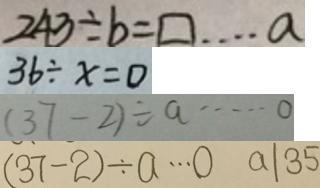<formula> <loc_0><loc_0><loc_500><loc_500>2 4 3 \div b = \square \cdots a 
 3 6 \div x = 0 
 ( 3 7 - 2 ) \div a \cdots 0 
 ( 3 7 - 2 ) \div a \cdots 0 a \vert 3 5</formula> 